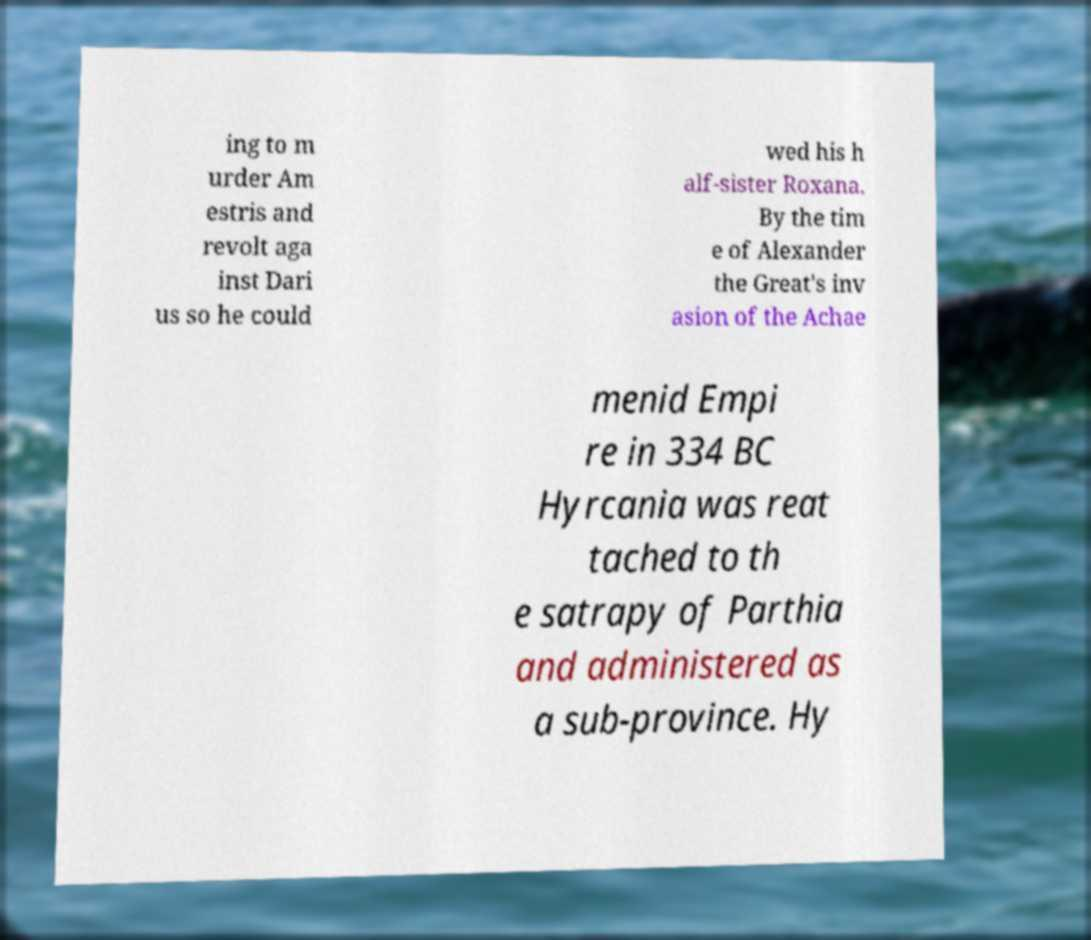Could you extract and type out the text from this image? ing to m urder Am estris and revolt aga inst Dari us so he could wed his h alf-sister Roxana. By the tim e of Alexander the Great's inv asion of the Achae menid Empi re in 334 BC Hyrcania was reat tached to th e satrapy of Parthia and administered as a sub-province. Hy 